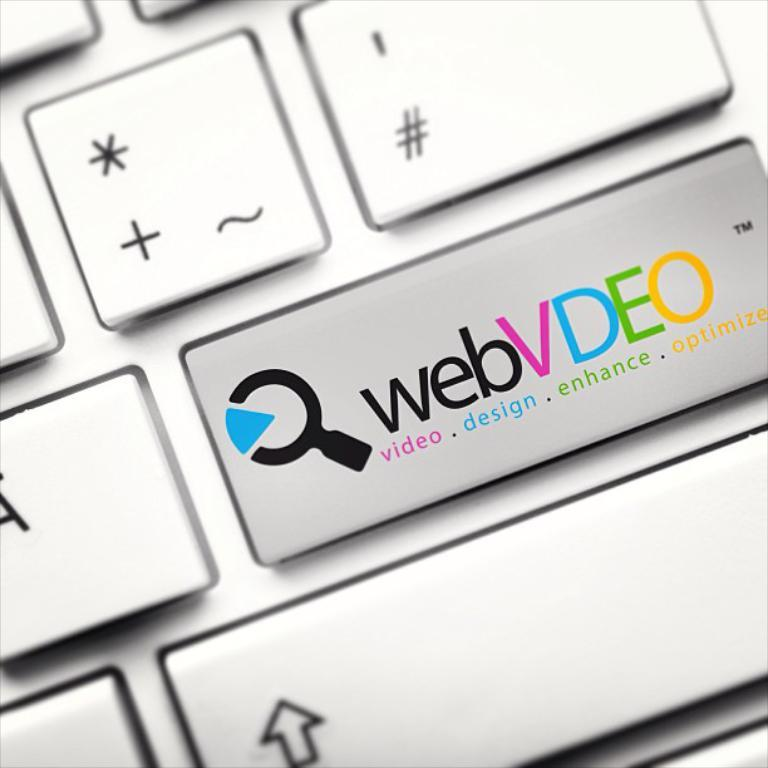<image>
Present a compact description of the photo's key features. A keyboard key has webVDEO video.design.enhance.optimize on it. 